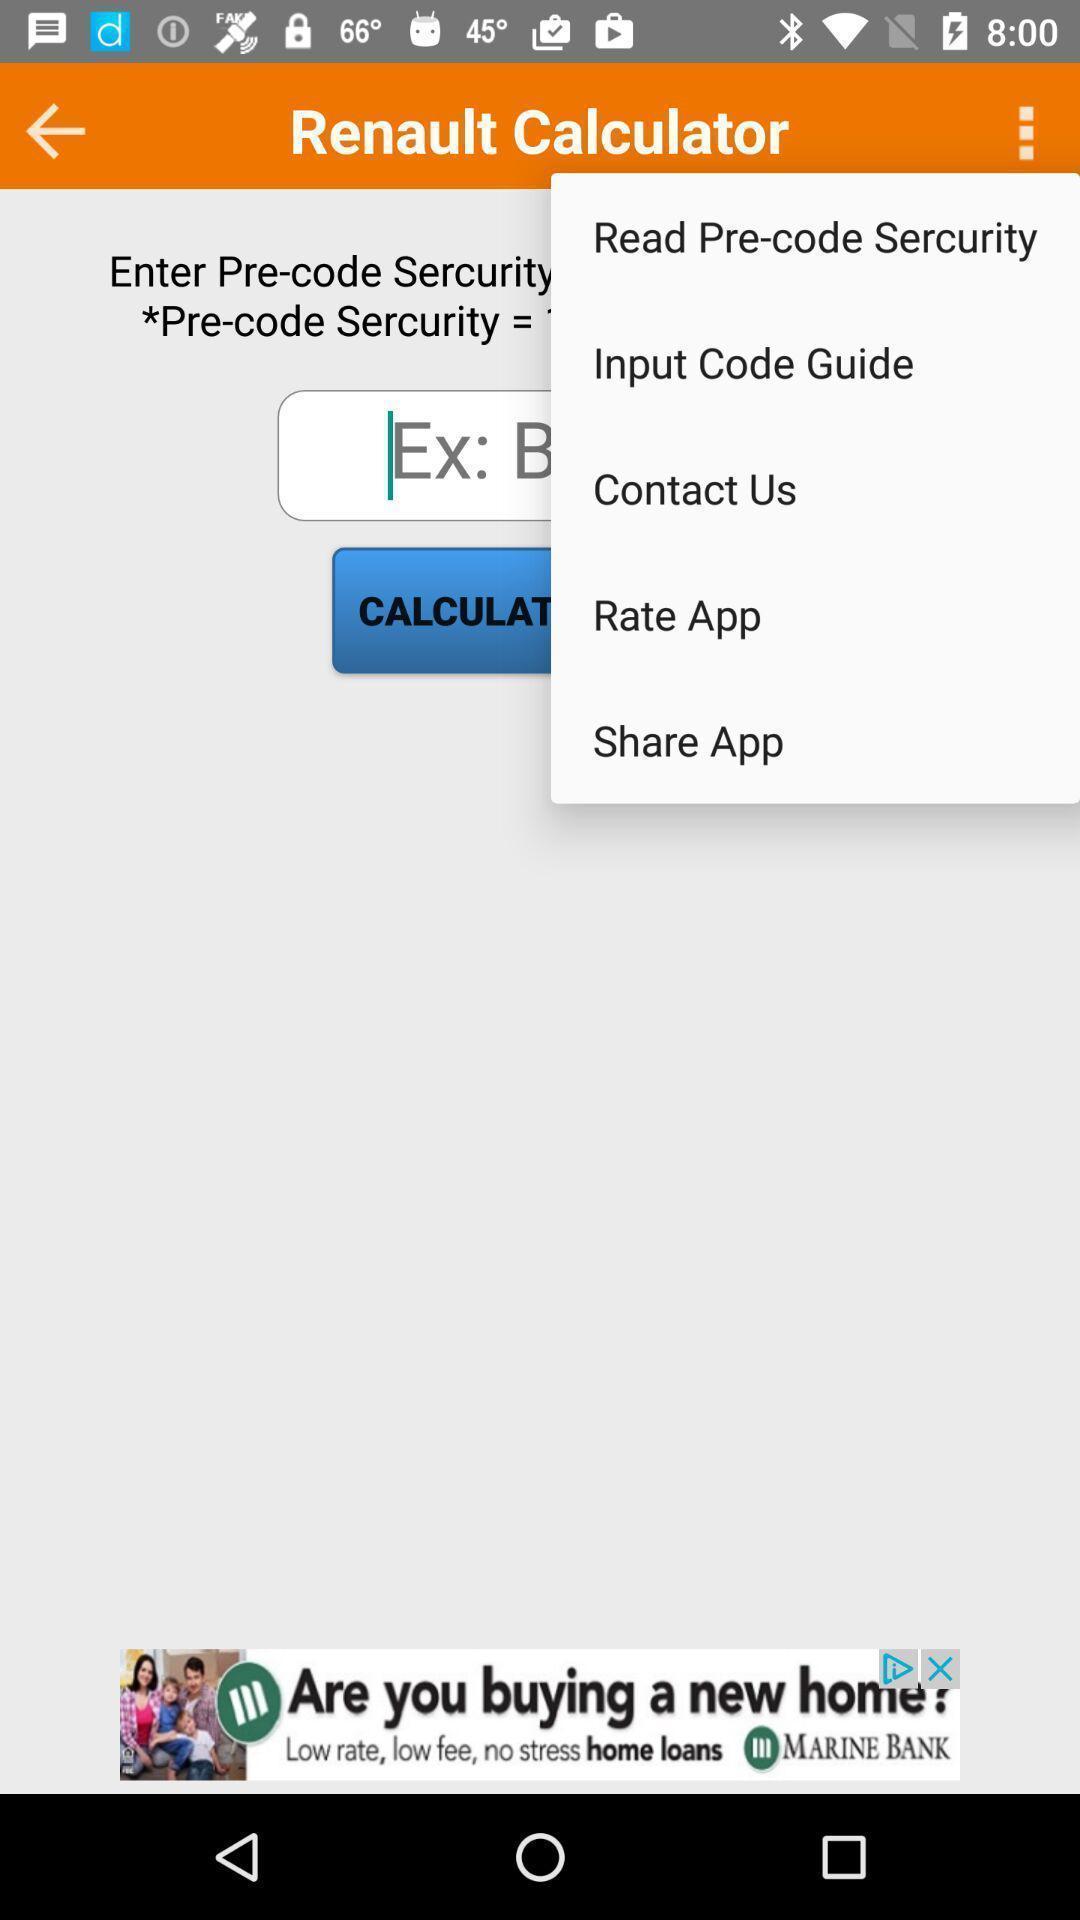Describe the key features of this screenshot. Pop-up showing the multiple options. 